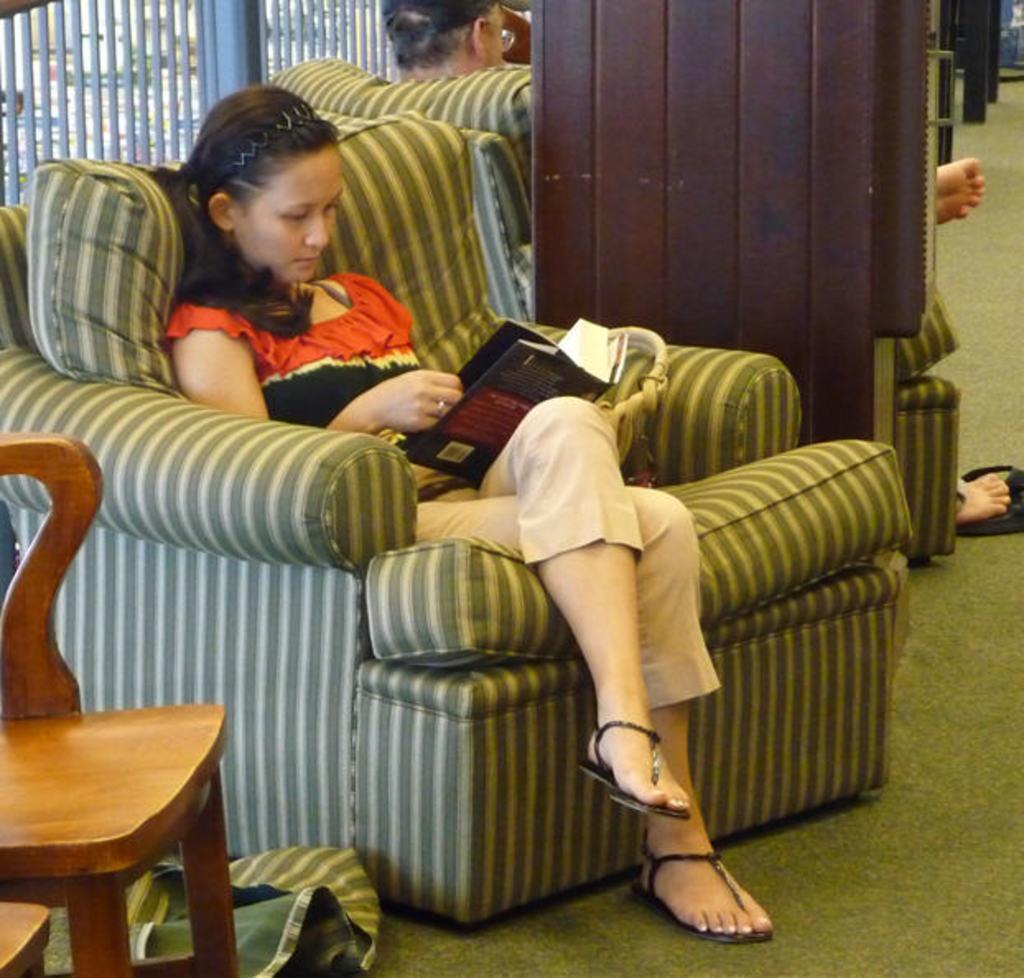Could you give a brief overview of what you see in this image? A woman is sitting in sofa and reading a book. 